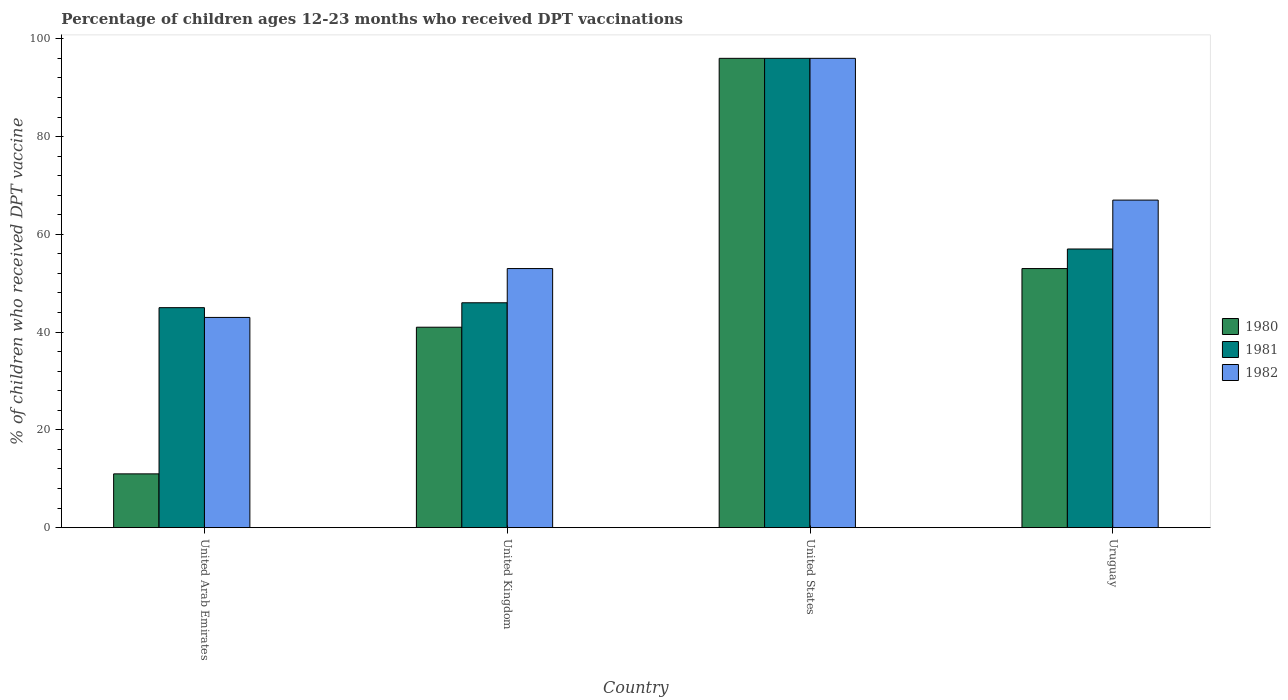How many groups of bars are there?
Your response must be concise. 4. Are the number of bars per tick equal to the number of legend labels?
Provide a short and direct response. Yes. How many bars are there on the 2nd tick from the right?
Offer a very short reply. 3. Across all countries, what is the maximum percentage of children who received DPT vaccination in 1982?
Offer a terse response. 96. In which country was the percentage of children who received DPT vaccination in 1980 minimum?
Offer a very short reply. United Arab Emirates. What is the total percentage of children who received DPT vaccination in 1980 in the graph?
Keep it short and to the point. 201. What is the difference between the percentage of children who received DPT vaccination in 1982 in United Kingdom and that in Uruguay?
Keep it short and to the point. -14. What is the difference between the percentage of children who received DPT vaccination in 1982 in United Arab Emirates and the percentage of children who received DPT vaccination in 1980 in United States?
Your response must be concise. -53. What is the average percentage of children who received DPT vaccination in 1980 per country?
Offer a very short reply. 50.25. What is the difference between the percentage of children who received DPT vaccination of/in 1981 and percentage of children who received DPT vaccination of/in 1982 in United States?
Keep it short and to the point. 0. In how many countries, is the percentage of children who received DPT vaccination in 1982 greater than 92 %?
Ensure brevity in your answer.  1. What is the ratio of the percentage of children who received DPT vaccination in 1980 in United Arab Emirates to that in Uruguay?
Keep it short and to the point. 0.21. What is the difference between the highest and the second highest percentage of children who received DPT vaccination in 1982?
Ensure brevity in your answer.  29. In how many countries, is the percentage of children who received DPT vaccination in 1982 greater than the average percentage of children who received DPT vaccination in 1982 taken over all countries?
Your response must be concise. 2. Is the sum of the percentage of children who received DPT vaccination in 1981 in United States and Uruguay greater than the maximum percentage of children who received DPT vaccination in 1980 across all countries?
Your answer should be very brief. Yes. What does the 1st bar from the left in United Arab Emirates represents?
Your answer should be very brief. 1980. What does the 1st bar from the right in United Kingdom represents?
Ensure brevity in your answer.  1982. Are all the bars in the graph horizontal?
Your response must be concise. No. How many countries are there in the graph?
Give a very brief answer. 4. Where does the legend appear in the graph?
Ensure brevity in your answer.  Center right. How many legend labels are there?
Make the answer very short. 3. What is the title of the graph?
Offer a terse response. Percentage of children ages 12-23 months who received DPT vaccinations. What is the label or title of the X-axis?
Ensure brevity in your answer.  Country. What is the label or title of the Y-axis?
Your answer should be very brief. % of children who received DPT vaccine. What is the % of children who received DPT vaccine of 1980 in United Arab Emirates?
Your answer should be compact. 11. What is the % of children who received DPT vaccine of 1980 in United Kingdom?
Your answer should be compact. 41. What is the % of children who received DPT vaccine in 1982 in United Kingdom?
Offer a terse response. 53. What is the % of children who received DPT vaccine in 1980 in United States?
Ensure brevity in your answer.  96. What is the % of children who received DPT vaccine in 1981 in United States?
Keep it short and to the point. 96. What is the % of children who received DPT vaccine in 1982 in United States?
Your answer should be compact. 96. What is the % of children who received DPT vaccine in 1980 in Uruguay?
Your answer should be very brief. 53. What is the % of children who received DPT vaccine of 1982 in Uruguay?
Offer a terse response. 67. Across all countries, what is the maximum % of children who received DPT vaccine in 1980?
Your response must be concise. 96. Across all countries, what is the maximum % of children who received DPT vaccine in 1981?
Offer a very short reply. 96. Across all countries, what is the maximum % of children who received DPT vaccine of 1982?
Ensure brevity in your answer.  96. Across all countries, what is the minimum % of children who received DPT vaccine in 1980?
Your response must be concise. 11. Across all countries, what is the minimum % of children who received DPT vaccine in 1982?
Provide a succinct answer. 43. What is the total % of children who received DPT vaccine of 1980 in the graph?
Keep it short and to the point. 201. What is the total % of children who received DPT vaccine of 1981 in the graph?
Your answer should be compact. 244. What is the total % of children who received DPT vaccine in 1982 in the graph?
Make the answer very short. 259. What is the difference between the % of children who received DPT vaccine of 1980 in United Arab Emirates and that in United Kingdom?
Your answer should be very brief. -30. What is the difference between the % of children who received DPT vaccine in 1980 in United Arab Emirates and that in United States?
Your response must be concise. -85. What is the difference between the % of children who received DPT vaccine in 1981 in United Arab Emirates and that in United States?
Offer a very short reply. -51. What is the difference between the % of children who received DPT vaccine of 1982 in United Arab Emirates and that in United States?
Make the answer very short. -53. What is the difference between the % of children who received DPT vaccine in 1980 in United Arab Emirates and that in Uruguay?
Offer a very short reply. -42. What is the difference between the % of children who received DPT vaccine of 1981 in United Arab Emirates and that in Uruguay?
Ensure brevity in your answer.  -12. What is the difference between the % of children who received DPT vaccine of 1982 in United Arab Emirates and that in Uruguay?
Your response must be concise. -24. What is the difference between the % of children who received DPT vaccine of 1980 in United Kingdom and that in United States?
Provide a short and direct response. -55. What is the difference between the % of children who received DPT vaccine in 1981 in United Kingdom and that in United States?
Your answer should be compact. -50. What is the difference between the % of children who received DPT vaccine of 1982 in United Kingdom and that in United States?
Offer a terse response. -43. What is the difference between the % of children who received DPT vaccine in 1980 in United Kingdom and that in Uruguay?
Your response must be concise. -12. What is the difference between the % of children who received DPT vaccine of 1981 in United Kingdom and that in Uruguay?
Give a very brief answer. -11. What is the difference between the % of children who received DPT vaccine of 1980 in United States and that in Uruguay?
Ensure brevity in your answer.  43. What is the difference between the % of children who received DPT vaccine of 1980 in United Arab Emirates and the % of children who received DPT vaccine of 1981 in United Kingdom?
Offer a very short reply. -35. What is the difference between the % of children who received DPT vaccine in 1980 in United Arab Emirates and the % of children who received DPT vaccine in 1982 in United Kingdom?
Provide a succinct answer. -42. What is the difference between the % of children who received DPT vaccine of 1980 in United Arab Emirates and the % of children who received DPT vaccine of 1981 in United States?
Your answer should be very brief. -85. What is the difference between the % of children who received DPT vaccine of 1980 in United Arab Emirates and the % of children who received DPT vaccine of 1982 in United States?
Give a very brief answer. -85. What is the difference between the % of children who received DPT vaccine of 1981 in United Arab Emirates and the % of children who received DPT vaccine of 1982 in United States?
Make the answer very short. -51. What is the difference between the % of children who received DPT vaccine of 1980 in United Arab Emirates and the % of children who received DPT vaccine of 1981 in Uruguay?
Provide a succinct answer. -46. What is the difference between the % of children who received DPT vaccine in 1980 in United Arab Emirates and the % of children who received DPT vaccine in 1982 in Uruguay?
Provide a short and direct response. -56. What is the difference between the % of children who received DPT vaccine in 1980 in United Kingdom and the % of children who received DPT vaccine in 1981 in United States?
Provide a succinct answer. -55. What is the difference between the % of children who received DPT vaccine of 1980 in United Kingdom and the % of children who received DPT vaccine of 1982 in United States?
Make the answer very short. -55. What is the difference between the % of children who received DPT vaccine in 1980 in United Kingdom and the % of children who received DPT vaccine in 1982 in Uruguay?
Your response must be concise. -26. What is the difference between the % of children who received DPT vaccine of 1980 in United States and the % of children who received DPT vaccine of 1982 in Uruguay?
Ensure brevity in your answer.  29. What is the average % of children who received DPT vaccine of 1980 per country?
Make the answer very short. 50.25. What is the average % of children who received DPT vaccine in 1981 per country?
Offer a terse response. 61. What is the average % of children who received DPT vaccine in 1982 per country?
Provide a succinct answer. 64.75. What is the difference between the % of children who received DPT vaccine of 1980 and % of children who received DPT vaccine of 1981 in United Arab Emirates?
Make the answer very short. -34. What is the difference between the % of children who received DPT vaccine of 1980 and % of children who received DPT vaccine of 1982 in United Arab Emirates?
Keep it short and to the point. -32. What is the difference between the % of children who received DPT vaccine of 1981 and % of children who received DPT vaccine of 1982 in United Arab Emirates?
Offer a very short reply. 2. What is the difference between the % of children who received DPT vaccine in 1980 and % of children who received DPT vaccine in 1981 in United Kingdom?
Ensure brevity in your answer.  -5. What is the difference between the % of children who received DPT vaccine in 1981 and % of children who received DPT vaccine in 1982 in United Kingdom?
Keep it short and to the point. -7. What is the difference between the % of children who received DPT vaccine of 1980 and % of children who received DPT vaccine of 1982 in United States?
Ensure brevity in your answer.  0. What is the difference between the % of children who received DPT vaccine in 1981 and % of children who received DPT vaccine in 1982 in United States?
Make the answer very short. 0. What is the difference between the % of children who received DPT vaccine of 1980 and % of children who received DPT vaccine of 1981 in Uruguay?
Give a very brief answer. -4. What is the difference between the % of children who received DPT vaccine of 1981 and % of children who received DPT vaccine of 1982 in Uruguay?
Your response must be concise. -10. What is the ratio of the % of children who received DPT vaccine of 1980 in United Arab Emirates to that in United Kingdom?
Offer a terse response. 0.27. What is the ratio of the % of children who received DPT vaccine of 1981 in United Arab Emirates to that in United Kingdom?
Give a very brief answer. 0.98. What is the ratio of the % of children who received DPT vaccine of 1982 in United Arab Emirates to that in United Kingdom?
Provide a succinct answer. 0.81. What is the ratio of the % of children who received DPT vaccine of 1980 in United Arab Emirates to that in United States?
Keep it short and to the point. 0.11. What is the ratio of the % of children who received DPT vaccine in 1981 in United Arab Emirates to that in United States?
Give a very brief answer. 0.47. What is the ratio of the % of children who received DPT vaccine of 1982 in United Arab Emirates to that in United States?
Ensure brevity in your answer.  0.45. What is the ratio of the % of children who received DPT vaccine of 1980 in United Arab Emirates to that in Uruguay?
Offer a terse response. 0.21. What is the ratio of the % of children who received DPT vaccine in 1981 in United Arab Emirates to that in Uruguay?
Ensure brevity in your answer.  0.79. What is the ratio of the % of children who received DPT vaccine of 1982 in United Arab Emirates to that in Uruguay?
Ensure brevity in your answer.  0.64. What is the ratio of the % of children who received DPT vaccine in 1980 in United Kingdom to that in United States?
Give a very brief answer. 0.43. What is the ratio of the % of children who received DPT vaccine of 1981 in United Kingdom to that in United States?
Offer a terse response. 0.48. What is the ratio of the % of children who received DPT vaccine of 1982 in United Kingdom to that in United States?
Your answer should be very brief. 0.55. What is the ratio of the % of children who received DPT vaccine in 1980 in United Kingdom to that in Uruguay?
Make the answer very short. 0.77. What is the ratio of the % of children who received DPT vaccine in 1981 in United Kingdom to that in Uruguay?
Ensure brevity in your answer.  0.81. What is the ratio of the % of children who received DPT vaccine in 1982 in United Kingdom to that in Uruguay?
Provide a short and direct response. 0.79. What is the ratio of the % of children who received DPT vaccine in 1980 in United States to that in Uruguay?
Give a very brief answer. 1.81. What is the ratio of the % of children who received DPT vaccine of 1981 in United States to that in Uruguay?
Your answer should be very brief. 1.68. What is the ratio of the % of children who received DPT vaccine of 1982 in United States to that in Uruguay?
Give a very brief answer. 1.43. What is the difference between the highest and the second highest % of children who received DPT vaccine in 1980?
Your answer should be compact. 43. What is the difference between the highest and the second highest % of children who received DPT vaccine in 1981?
Keep it short and to the point. 39. What is the difference between the highest and the second highest % of children who received DPT vaccine in 1982?
Provide a short and direct response. 29. What is the difference between the highest and the lowest % of children who received DPT vaccine in 1982?
Offer a very short reply. 53. 